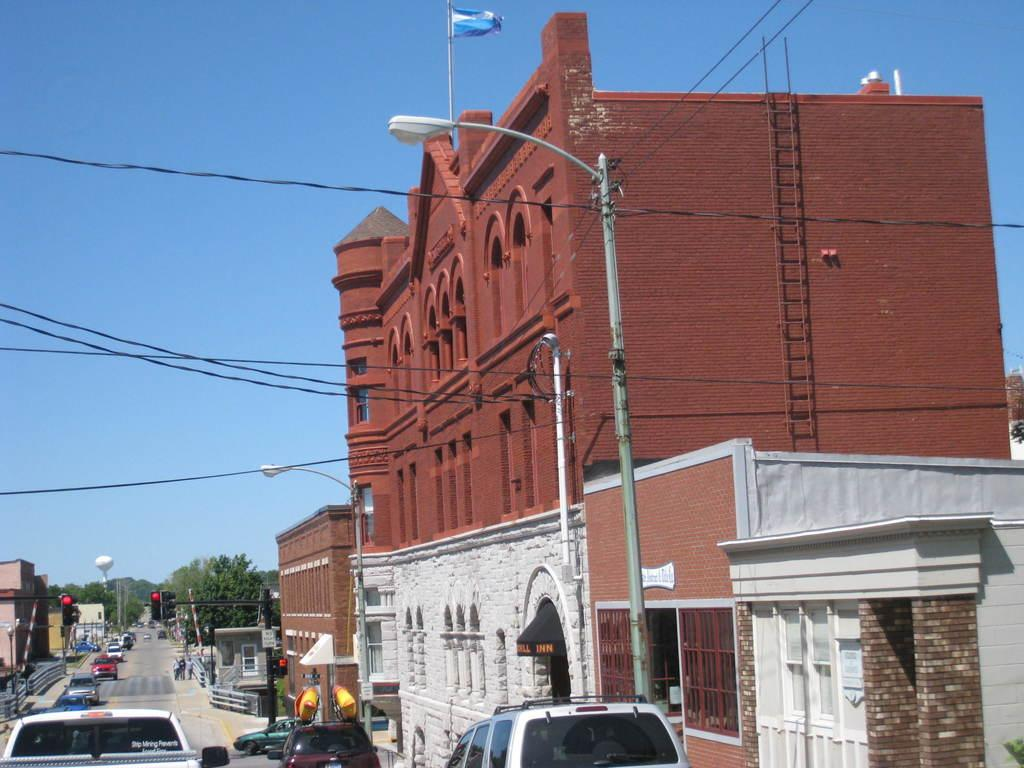What type of structure is present in the image? There is a building in the image. What else can be seen in the image besides the building? There are electrical poles, cars on the road, trees, and a tower visible in the image. How many eggs are visible on the tower in the image? There are no eggs present on the tower in the image. What direction are the cars on the road in the image traveling? The direction of the cars cannot be determined from the image alone, as we cannot see the road markings or traffic signals. 